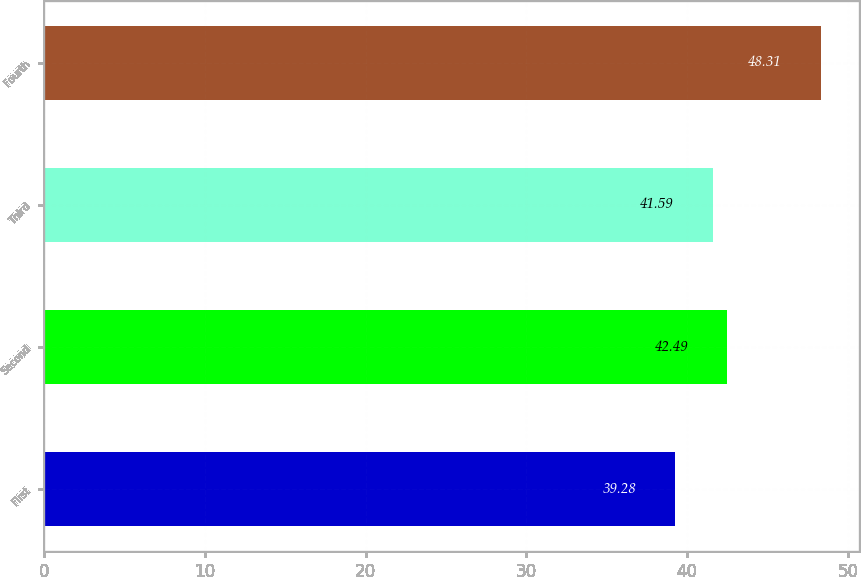<chart> <loc_0><loc_0><loc_500><loc_500><bar_chart><fcel>First<fcel>Second<fcel>Third<fcel>Fourth<nl><fcel>39.28<fcel>42.49<fcel>41.59<fcel>48.31<nl></chart> 